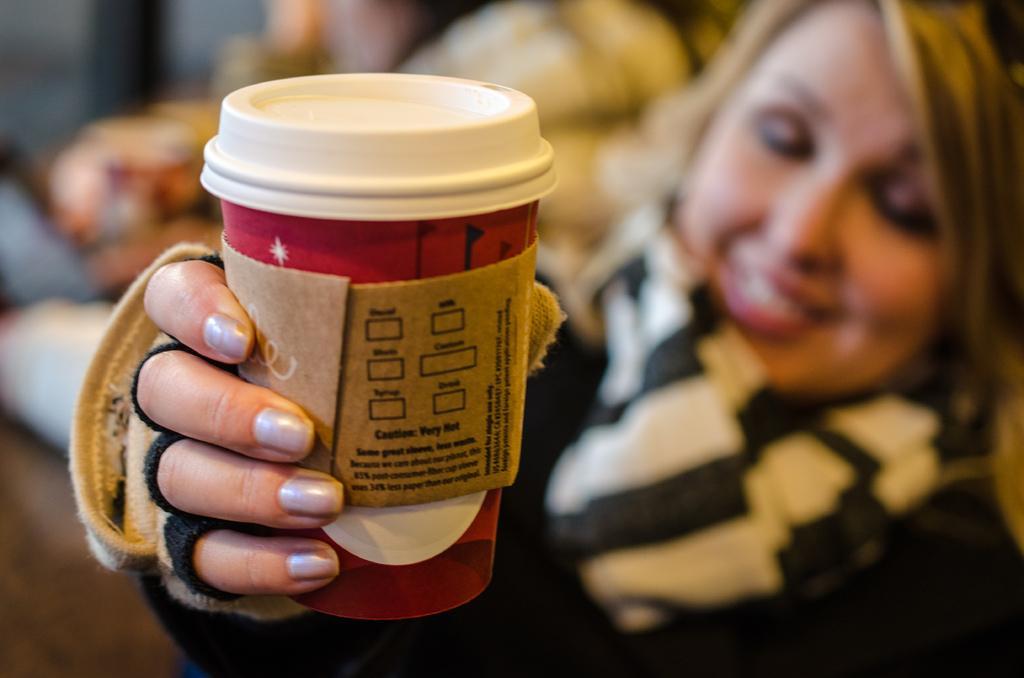Can you describe this image briefly? In the center of the image we can see a person in a different costume. And we can see she is smiling and she is holding some object. In the background, we can see it is blurred. 